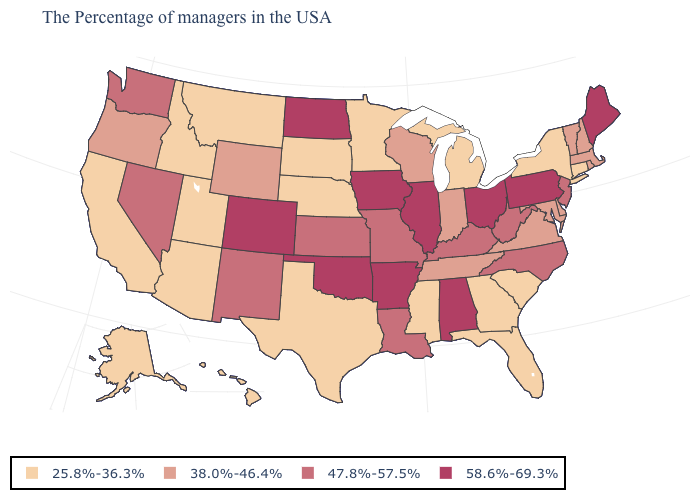What is the value of Georgia?
Be succinct. 25.8%-36.3%. How many symbols are there in the legend?
Keep it brief. 4. Name the states that have a value in the range 25.8%-36.3%?
Keep it brief. Connecticut, New York, South Carolina, Florida, Georgia, Michigan, Mississippi, Minnesota, Nebraska, Texas, South Dakota, Utah, Montana, Arizona, Idaho, California, Alaska, Hawaii. What is the value of Kansas?
Keep it brief. 47.8%-57.5%. Does the first symbol in the legend represent the smallest category?
Quick response, please. Yes. What is the value of Maine?
Write a very short answer. 58.6%-69.3%. What is the value of New York?
Short answer required. 25.8%-36.3%. Does Nebraska have the lowest value in the USA?
Give a very brief answer. Yes. What is the lowest value in states that border Colorado?
Be succinct. 25.8%-36.3%. What is the value of Massachusetts?
Short answer required. 38.0%-46.4%. Among the states that border New Hampshire , which have the highest value?
Give a very brief answer. Maine. Does Georgia have the lowest value in the USA?
Quick response, please. Yes. What is the value of Nevada?
Short answer required. 47.8%-57.5%. What is the value of Georgia?
Quick response, please. 25.8%-36.3%. Name the states that have a value in the range 47.8%-57.5%?
Quick response, please. New Jersey, North Carolina, West Virginia, Kentucky, Louisiana, Missouri, Kansas, New Mexico, Nevada, Washington. 